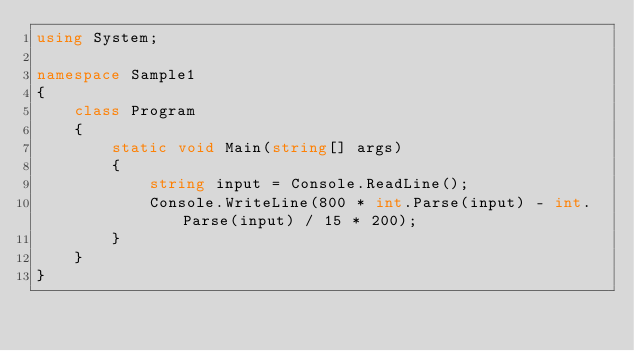<code> <loc_0><loc_0><loc_500><loc_500><_C#_>using System;

namespace Sample1
{
    class Program
    {
        static void Main(string[] args)
        {
            string input = Console.ReadLine();
            Console.WriteLine(800 * int.Parse(input) - int.Parse(input) / 15 * 200);
        }
    }
}</code> 